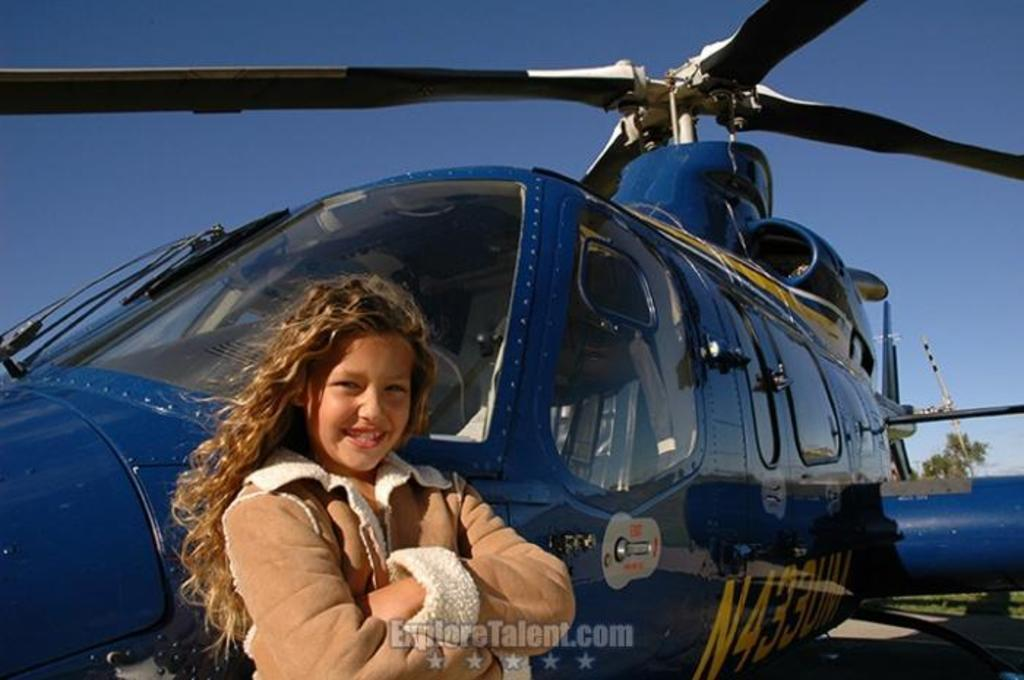Provide a one-sentence caption for the provided image. A young girl poses in front of a blue helicopter with the call number N433UM. 